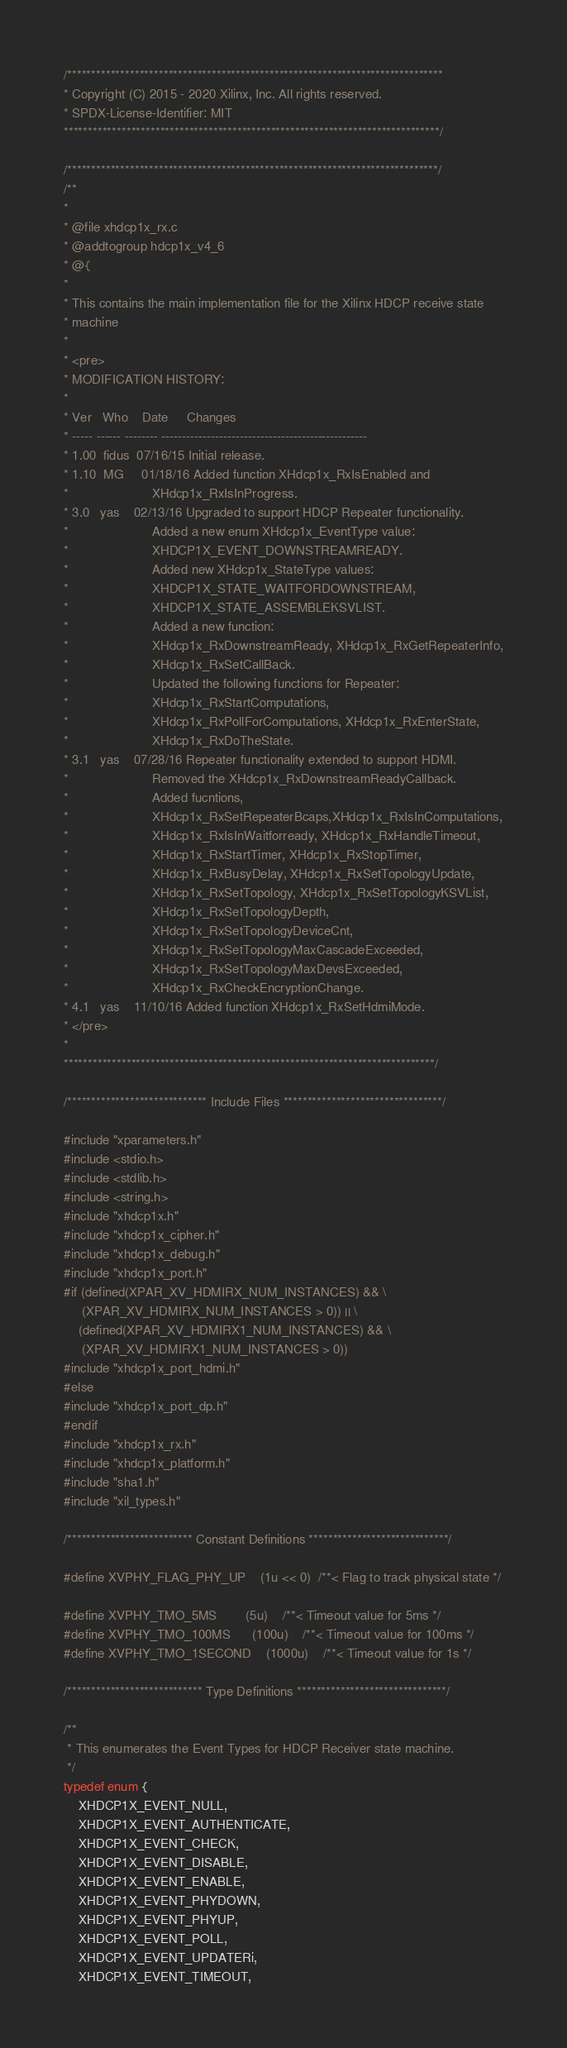<code> <loc_0><loc_0><loc_500><loc_500><_C_>/******************************************************************************
* Copyright (C) 2015 - 2020 Xilinx, Inc. All rights reserved.
* SPDX-License-Identifier: MIT
******************************************************************************/

/*****************************************************************************/
/**
*
* @file xhdcp1x_rx.c
* @addtogroup hdcp1x_v4_6
* @{
*
* This contains the main implementation file for the Xilinx HDCP receive state
* machine
*
* <pre>
* MODIFICATION HISTORY:
*
* Ver   Who    Date     Changes
* ----- ------ -------- --------------------------------------------------
* 1.00  fidus  07/16/15 Initial release.
* 1.10  MG     01/18/16 Added function XHdcp1x_RxIsEnabled and
*                       XHdcp1x_RxIsInProgress.
* 3.0   yas    02/13/16 Upgraded to support HDCP Repeater functionality.
*                       Added a new enum XHdcp1x_EventType value:
*                       XHDCP1X_EVENT_DOWNSTREAMREADY.
*                       Added new XHdcp1x_StateType values:
*                       XHDCP1X_STATE_WAITFORDOWNSTREAM,
*                       XHDCP1X_STATE_ASSEMBLEKSVLIST.
*                       Added a new function:
*                       XHdcp1x_RxDownstreamReady, XHdcp1x_RxGetRepeaterInfo,
*                       XHdcp1x_RxSetCallBack.
*                       Updated the following functions for Repeater:
*                       XHdcp1x_RxStartComputations,
*                       XHdcp1x_RxPollForComputations, XHdcp1x_RxEnterState,
*                       XHdcp1x_RxDoTheState.
* 3.1   yas    07/28/16 Repeater functionality extended to support HDMI.
*                       Removed the XHdcp1x_RxDownstreamReadyCallback.
*                       Added fucntions,
*                       XHdcp1x_RxSetRepeaterBcaps,XHdcp1x_RxIsInComputations,
*                       XHdcp1x_RxIsInWaitforready, XHdcp1x_RxHandleTimeout,
*                       XHdcp1x_RxStartTimer, XHdcp1x_RxStopTimer,
*                       XHdcp1x_RxBusyDelay, XHdcp1x_RxSetTopologyUpdate,
*                       XHdcp1x_RxSetTopology, XHdcp1x_RxSetTopologyKSVList,
*                       XHdcp1x_RxSetTopologyDepth,
*                       XHdcp1x_RxSetTopologyDeviceCnt,
*                       XHdcp1x_RxSetTopologyMaxCascadeExceeded,
*                       XHdcp1x_RxSetTopologyMaxDevsExceeded,
*                       XHdcp1x_RxCheckEncryptionChange.
* 4.1   yas    11/10/16 Added function XHdcp1x_RxSetHdmiMode.
* </pre>
*
*****************************************************************************/

/***************************** Include Files *********************************/

#include "xparameters.h"
#include <stdio.h>
#include <stdlib.h>
#include <string.h>
#include "xhdcp1x.h"
#include "xhdcp1x_cipher.h"
#include "xhdcp1x_debug.h"
#include "xhdcp1x_port.h"
#if (defined(XPAR_XV_HDMIRX_NUM_INSTANCES) && \
     (XPAR_XV_HDMIRX_NUM_INSTANCES > 0)) || \
    (defined(XPAR_XV_HDMIRX1_NUM_INSTANCES) && \
     (XPAR_XV_HDMIRX1_NUM_INSTANCES > 0))
#include "xhdcp1x_port_hdmi.h"
#else
#include "xhdcp1x_port_dp.h"
#endif
#include "xhdcp1x_rx.h"
#include "xhdcp1x_platform.h"
#include "sha1.h"
#include "xil_types.h"

/************************** Constant Definitions *****************************/

#define XVPHY_FLAG_PHY_UP	(1u << 0)  /**< Flag to track physical state */

#define XVPHY_TMO_5MS		(5u)    /**< Timeout value for 5ms */
#define XVPHY_TMO_100MS		(100u)    /**< Timeout value for 100ms */
#define XVPHY_TMO_1SECOND	(1000u)    /**< Timeout value for 1s */

/**************************** Type Definitions *******************************/

/**
 * This enumerates the Event Types for HDCP Receiver state machine.
 */
typedef enum {
	XHDCP1X_EVENT_NULL,
	XHDCP1X_EVENT_AUTHENTICATE,
	XHDCP1X_EVENT_CHECK,
	XHDCP1X_EVENT_DISABLE,
	XHDCP1X_EVENT_ENABLE,
	XHDCP1X_EVENT_PHYDOWN,
	XHDCP1X_EVENT_PHYUP,
	XHDCP1X_EVENT_POLL,
	XHDCP1X_EVENT_UPDATERi,
	XHDCP1X_EVENT_TIMEOUT,</code> 